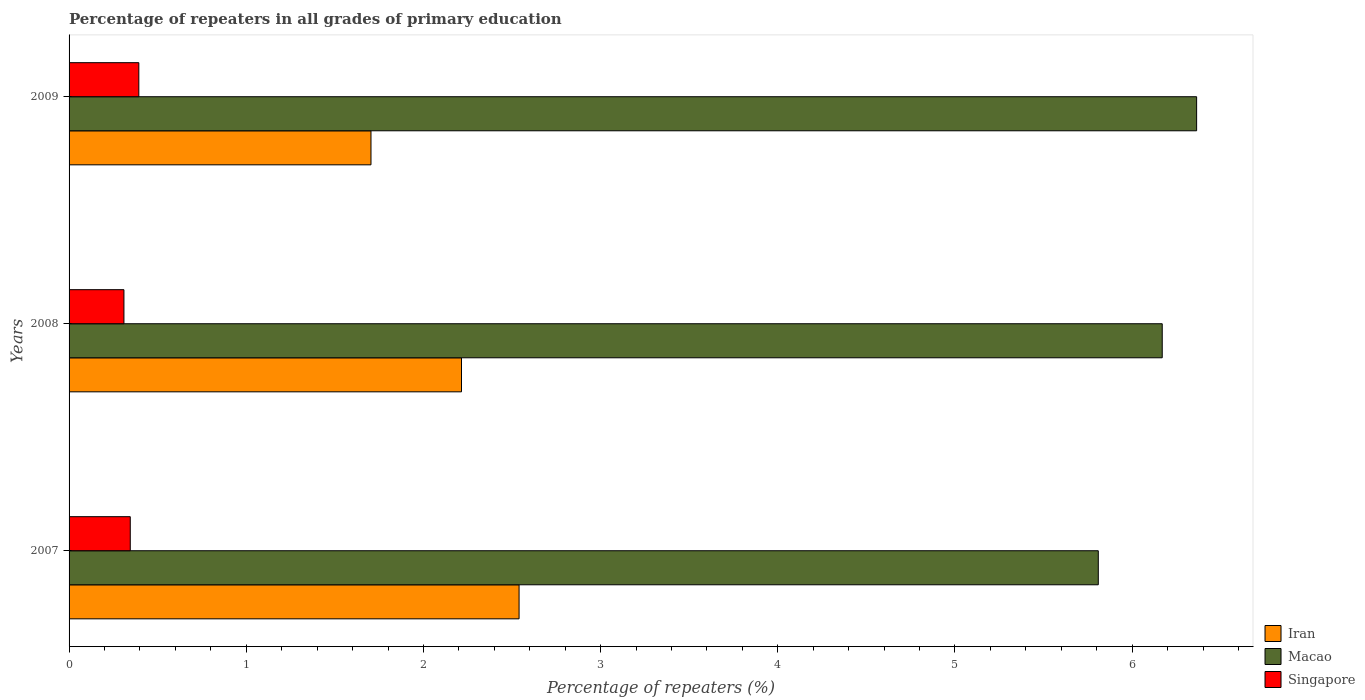How many different coloured bars are there?
Your response must be concise. 3. Are the number of bars on each tick of the Y-axis equal?
Offer a very short reply. Yes. How many bars are there on the 2nd tick from the top?
Provide a succinct answer. 3. How many bars are there on the 2nd tick from the bottom?
Provide a succinct answer. 3. In how many cases, is the number of bars for a given year not equal to the number of legend labels?
Provide a short and direct response. 0. What is the percentage of repeaters in Iran in 2009?
Offer a very short reply. 1.7. Across all years, what is the maximum percentage of repeaters in Iran?
Offer a terse response. 2.54. Across all years, what is the minimum percentage of repeaters in Iran?
Offer a very short reply. 1.7. In which year was the percentage of repeaters in Iran minimum?
Your response must be concise. 2009. What is the total percentage of repeaters in Macao in the graph?
Keep it short and to the point. 18.34. What is the difference between the percentage of repeaters in Macao in 2007 and that in 2009?
Keep it short and to the point. -0.55. What is the difference between the percentage of repeaters in Singapore in 2008 and the percentage of repeaters in Macao in 2007?
Offer a very short reply. -5.5. What is the average percentage of repeaters in Singapore per year?
Your response must be concise. 0.35. In the year 2007, what is the difference between the percentage of repeaters in Macao and percentage of repeaters in Iran?
Your response must be concise. 3.27. In how many years, is the percentage of repeaters in Macao greater than 3.6 %?
Your answer should be very brief. 3. What is the ratio of the percentage of repeaters in Macao in 2007 to that in 2008?
Give a very brief answer. 0.94. Is the difference between the percentage of repeaters in Macao in 2008 and 2009 greater than the difference between the percentage of repeaters in Iran in 2008 and 2009?
Provide a short and direct response. No. What is the difference between the highest and the second highest percentage of repeaters in Macao?
Ensure brevity in your answer.  0.19. What is the difference between the highest and the lowest percentage of repeaters in Singapore?
Your answer should be compact. 0.08. In how many years, is the percentage of repeaters in Macao greater than the average percentage of repeaters in Macao taken over all years?
Ensure brevity in your answer.  2. Is the sum of the percentage of repeaters in Macao in 2007 and 2009 greater than the maximum percentage of repeaters in Iran across all years?
Give a very brief answer. Yes. What does the 1st bar from the top in 2009 represents?
Make the answer very short. Singapore. What does the 1st bar from the bottom in 2007 represents?
Give a very brief answer. Iran. Is it the case that in every year, the sum of the percentage of repeaters in Macao and percentage of repeaters in Singapore is greater than the percentage of repeaters in Iran?
Your response must be concise. Yes. How many bars are there?
Provide a short and direct response. 9. Are all the bars in the graph horizontal?
Offer a terse response. Yes. Are the values on the major ticks of X-axis written in scientific E-notation?
Ensure brevity in your answer.  No. Does the graph contain any zero values?
Provide a succinct answer. No. How are the legend labels stacked?
Offer a terse response. Vertical. What is the title of the graph?
Offer a very short reply. Percentage of repeaters in all grades of primary education. What is the label or title of the X-axis?
Provide a succinct answer. Percentage of repeaters (%). What is the label or title of the Y-axis?
Ensure brevity in your answer.  Years. What is the Percentage of repeaters (%) of Iran in 2007?
Ensure brevity in your answer.  2.54. What is the Percentage of repeaters (%) in Macao in 2007?
Your response must be concise. 5.81. What is the Percentage of repeaters (%) of Singapore in 2007?
Your response must be concise. 0.35. What is the Percentage of repeaters (%) of Iran in 2008?
Give a very brief answer. 2.21. What is the Percentage of repeaters (%) of Macao in 2008?
Your response must be concise. 6.17. What is the Percentage of repeaters (%) of Singapore in 2008?
Your answer should be compact. 0.31. What is the Percentage of repeaters (%) of Iran in 2009?
Give a very brief answer. 1.7. What is the Percentage of repeaters (%) in Macao in 2009?
Give a very brief answer. 6.36. What is the Percentage of repeaters (%) in Singapore in 2009?
Provide a short and direct response. 0.39. Across all years, what is the maximum Percentage of repeaters (%) of Iran?
Your answer should be compact. 2.54. Across all years, what is the maximum Percentage of repeaters (%) in Macao?
Provide a succinct answer. 6.36. Across all years, what is the maximum Percentage of repeaters (%) of Singapore?
Your response must be concise. 0.39. Across all years, what is the minimum Percentage of repeaters (%) in Iran?
Your response must be concise. 1.7. Across all years, what is the minimum Percentage of repeaters (%) of Macao?
Give a very brief answer. 5.81. Across all years, what is the minimum Percentage of repeaters (%) of Singapore?
Keep it short and to the point. 0.31. What is the total Percentage of repeaters (%) of Iran in the graph?
Make the answer very short. 6.46. What is the total Percentage of repeaters (%) in Macao in the graph?
Give a very brief answer. 18.34. What is the total Percentage of repeaters (%) in Singapore in the graph?
Your answer should be compact. 1.05. What is the difference between the Percentage of repeaters (%) in Iran in 2007 and that in 2008?
Your answer should be compact. 0.32. What is the difference between the Percentage of repeaters (%) in Macao in 2007 and that in 2008?
Your response must be concise. -0.36. What is the difference between the Percentage of repeaters (%) in Singapore in 2007 and that in 2008?
Keep it short and to the point. 0.04. What is the difference between the Percentage of repeaters (%) in Iran in 2007 and that in 2009?
Ensure brevity in your answer.  0.84. What is the difference between the Percentage of repeaters (%) of Macao in 2007 and that in 2009?
Offer a very short reply. -0.56. What is the difference between the Percentage of repeaters (%) in Singapore in 2007 and that in 2009?
Provide a short and direct response. -0.05. What is the difference between the Percentage of repeaters (%) in Iran in 2008 and that in 2009?
Offer a terse response. 0.51. What is the difference between the Percentage of repeaters (%) of Macao in 2008 and that in 2009?
Make the answer very short. -0.19. What is the difference between the Percentage of repeaters (%) in Singapore in 2008 and that in 2009?
Provide a short and direct response. -0.08. What is the difference between the Percentage of repeaters (%) in Iran in 2007 and the Percentage of repeaters (%) in Macao in 2008?
Ensure brevity in your answer.  -3.63. What is the difference between the Percentage of repeaters (%) of Iran in 2007 and the Percentage of repeaters (%) of Singapore in 2008?
Offer a terse response. 2.23. What is the difference between the Percentage of repeaters (%) of Macao in 2007 and the Percentage of repeaters (%) of Singapore in 2008?
Offer a very short reply. 5.5. What is the difference between the Percentage of repeaters (%) in Iran in 2007 and the Percentage of repeaters (%) in Macao in 2009?
Provide a short and direct response. -3.82. What is the difference between the Percentage of repeaters (%) of Iran in 2007 and the Percentage of repeaters (%) of Singapore in 2009?
Your response must be concise. 2.15. What is the difference between the Percentage of repeaters (%) in Macao in 2007 and the Percentage of repeaters (%) in Singapore in 2009?
Provide a succinct answer. 5.42. What is the difference between the Percentage of repeaters (%) of Iran in 2008 and the Percentage of repeaters (%) of Macao in 2009?
Keep it short and to the point. -4.15. What is the difference between the Percentage of repeaters (%) of Iran in 2008 and the Percentage of repeaters (%) of Singapore in 2009?
Make the answer very short. 1.82. What is the difference between the Percentage of repeaters (%) of Macao in 2008 and the Percentage of repeaters (%) of Singapore in 2009?
Offer a terse response. 5.78. What is the average Percentage of repeaters (%) of Iran per year?
Provide a short and direct response. 2.15. What is the average Percentage of repeaters (%) in Macao per year?
Your answer should be compact. 6.11. What is the average Percentage of repeaters (%) in Singapore per year?
Offer a very short reply. 0.35. In the year 2007, what is the difference between the Percentage of repeaters (%) of Iran and Percentage of repeaters (%) of Macao?
Ensure brevity in your answer.  -3.27. In the year 2007, what is the difference between the Percentage of repeaters (%) of Iran and Percentage of repeaters (%) of Singapore?
Ensure brevity in your answer.  2.19. In the year 2007, what is the difference between the Percentage of repeaters (%) of Macao and Percentage of repeaters (%) of Singapore?
Offer a terse response. 5.46. In the year 2008, what is the difference between the Percentage of repeaters (%) of Iran and Percentage of repeaters (%) of Macao?
Your answer should be very brief. -3.96. In the year 2008, what is the difference between the Percentage of repeaters (%) of Iran and Percentage of repeaters (%) of Singapore?
Provide a succinct answer. 1.91. In the year 2008, what is the difference between the Percentage of repeaters (%) in Macao and Percentage of repeaters (%) in Singapore?
Offer a terse response. 5.86. In the year 2009, what is the difference between the Percentage of repeaters (%) in Iran and Percentage of repeaters (%) in Macao?
Give a very brief answer. -4.66. In the year 2009, what is the difference between the Percentage of repeaters (%) in Iran and Percentage of repeaters (%) in Singapore?
Offer a very short reply. 1.31. In the year 2009, what is the difference between the Percentage of repeaters (%) of Macao and Percentage of repeaters (%) of Singapore?
Provide a succinct answer. 5.97. What is the ratio of the Percentage of repeaters (%) in Iran in 2007 to that in 2008?
Provide a succinct answer. 1.15. What is the ratio of the Percentage of repeaters (%) of Macao in 2007 to that in 2008?
Your answer should be very brief. 0.94. What is the ratio of the Percentage of repeaters (%) of Singapore in 2007 to that in 2008?
Provide a short and direct response. 1.12. What is the ratio of the Percentage of repeaters (%) of Iran in 2007 to that in 2009?
Ensure brevity in your answer.  1.49. What is the ratio of the Percentage of repeaters (%) of Macao in 2007 to that in 2009?
Offer a terse response. 0.91. What is the ratio of the Percentage of repeaters (%) of Singapore in 2007 to that in 2009?
Provide a short and direct response. 0.88. What is the ratio of the Percentage of repeaters (%) of Iran in 2008 to that in 2009?
Provide a short and direct response. 1.3. What is the ratio of the Percentage of repeaters (%) of Macao in 2008 to that in 2009?
Provide a succinct answer. 0.97. What is the ratio of the Percentage of repeaters (%) in Singapore in 2008 to that in 2009?
Offer a terse response. 0.79. What is the difference between the highest and the second highest Percentage of repeaters (%) of Iran?
Keep it short and to the point. 0.32. What is the difference between the highest and the second highest Percentage of repeaters (%) of Macao?
Give a very brief answer. 0.19. What is the difference between the highest and the second highest Percentage of repeaters (%) of Singapore?
Offer a terse response. 0.05. What is the difference between the highest and the lowest Percentage of repeaters (%) in Iran?
Ensure brevity in your answer.  0.84. What is the difference between the highest and the lowest Percentage of repeaters (%) in Macao?
Offer a terse response. 0.56. What is the difference between the highest and the lowest Percentage of repeaters (%) in Singapore?
Keep it short and to the point. 0.08. 